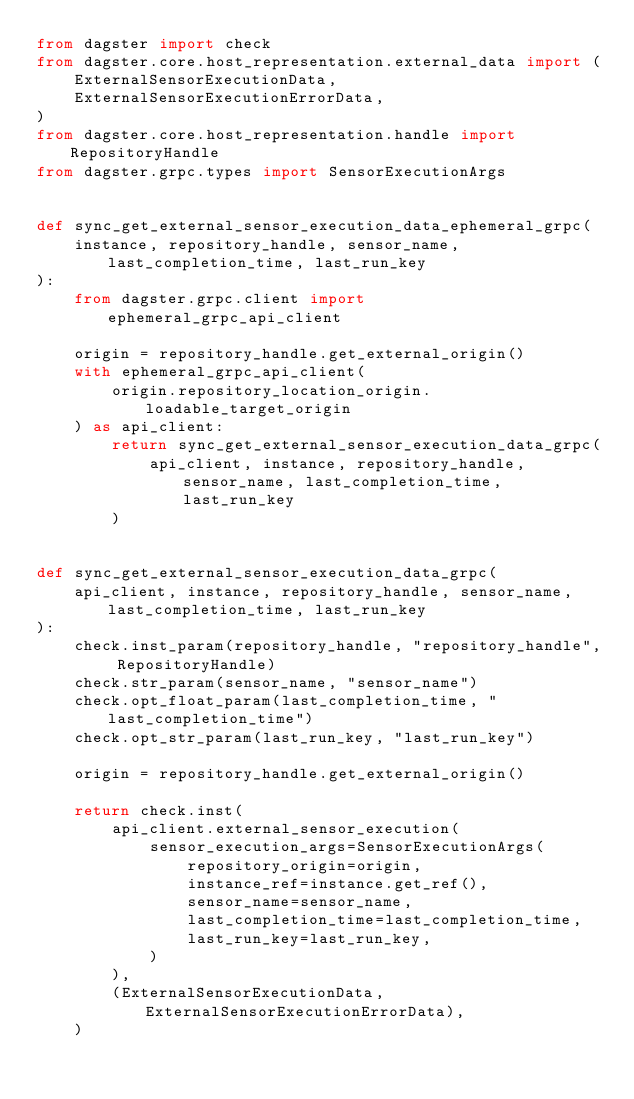Convert code to text. <code><loc_0><loc_0><loc_500><loc_500><_Python_>from dagster import check
from dagster.core.host_representation.external_data import (
    ExternalSensorExecutionData,
    ExternalSensorExecutionErrorData,
)
from dagster.core.host_representation.handle import RepositoryHandle
from dagster.grpc.types import SensorExecutionArgs


def sync_get_external_sensor_execution_data_ephemeral_grpc(
    instance, repository_handle, sensor_name, last_completion_time, last_run_key
):
    from dagster.grpc.client import ephemeral_grpc_api_client

    origin = repository_handle.get_external_origin()
    with ephemeral_grpc_api_client(
        origin.repository_location_origin.loadable_target_origin
    ) as api_client:
        return sync_get_external_sensor_execution_data_grpc(
            api_client, instance, repository_handle, sensor_name, last_completion_time, last_run_key
        )


def sync_get_external_sensor_execution_data_grpc(
    api_client, instance, repository_handle, sensor_name, last_completion_time, last_run_key
):
    check.inst_param(repository_handle, "repository_handle", RepositoryHandle)
    check.str_param(sensor_name, "sensor_name")
    check.opt_float_param(last_completion_time, "last_completion_time")
    check.opt_str_param(last_run_key, "last_run_key")

    origin = repository_handle.get_external_origin()

    return check.inst(
        api_client.external_sensor_execution(
            sensor_execution_args=SensorExecutionArgs(
                repository_origin=origin,
                instance_ref=instance.get_ref(),
                sensor_name=sensor_name,
                last_completion_time=last_completion_time,
                last_run_key=last_run_key,
            )
        ),
        (ExternalSensorExecutionData, ExternalSensorExecutionErrorData),
    )
</code> 